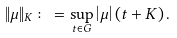Convert formula to latex. <formula><loc_0><loc_0><loc_500><loc_500>\| \mu \| _ { K } \colon = \sup _ { t \in G } \left | \mu \right | ( t + K ) \, .</formula> 